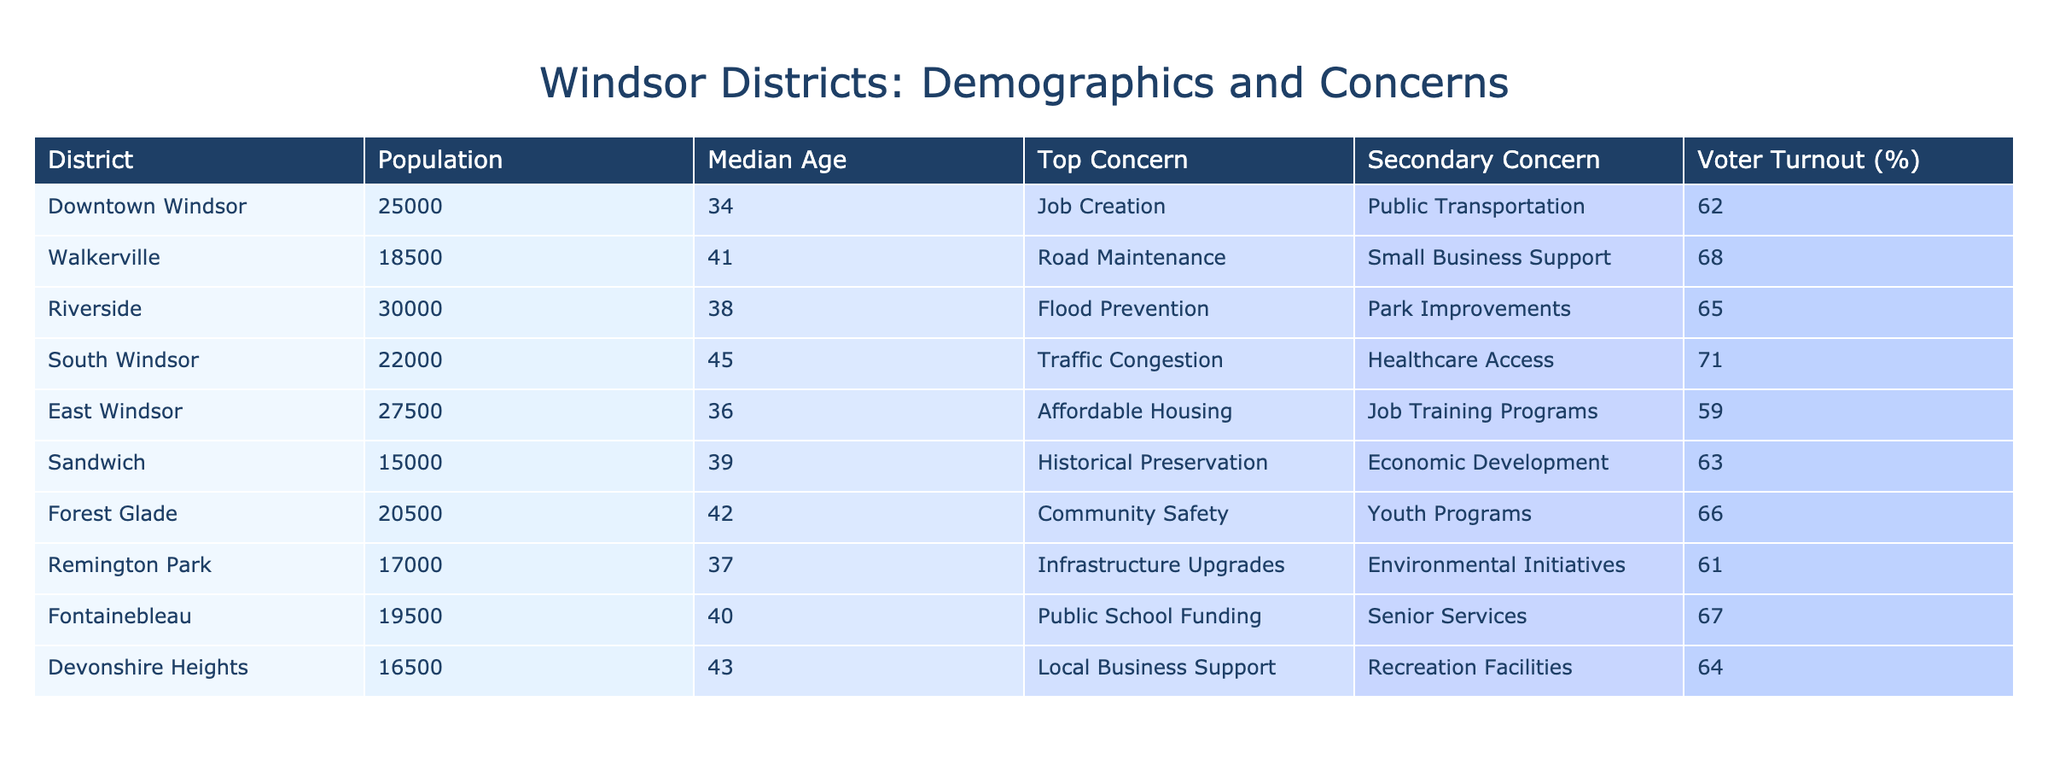What is the median age of residents in Riverside? The table lists Riverside with a median age of 38. Since the question is directly asking for a specific value in the table, it can be identified easily.
Answer: 38 Which district has the highest voter turnout percentage? By examining the voter turnout column, the district with the highest percentage is South Windsor at 71%. It is a direct retrieval question that looks for a specific value from the table.
Answer: South Windsor What is the average voter turnout for all districts? To calculate the average, sum the voter turnout percentages: (62 + 68 + 65 + 71 + 59 + 63 + 66 + 61 + 67 + 64) =  646. Then, divide by the number of districts (10): 646 / 10 = 64.6.
Answer: 64.6 Is job creation the top concern in East Windsor? The table states that the top concern in East Windsor is affordable housing, not job creation. Thus, this is a fact-based question that can be answered with a direct comparison from the table.
Answer: No Which district has traffic congestion as a concern? By checking the "Top Concern" column, it is clear that South Windsor has traffic congestion listed as a top concern. This question requires scanning through the table to find the relevant district.
Answer: South Windsor What are the secondary concerns for districts with a median age over 40? The districts with a median age over 40 are Walkerville (Small Business Support), South Windsor (Healthcare Access), Sandwich (Economic Development), and Devonshire Heights (Recreation Facilities). The secondary concerns are identified by filtering these districts from the table.
Answer: Small Business Support, Healthcare Access, Economic Development, Recreation Facilities How many districts have affordable housing as a top concern? The table shows that affordable housing is the top concern only in East Windsor. Thus, this requires checking the specific rows matching the concern.
Answer: 1 Are there more districts concerned about public transportation or road maintenance? By examining the top concerns: Public Transportation is the top concern in Downtown Windsor, and Road Maintenance is the top concern in Walkerville. There are equal concerns of 1 district each, resulting in a comparative analysis between two concerns across the districts.
Answer: Equal What is the total population of all districts combined? To find the total population, add the populations of all districts: (25000 + 18500 + 30000 + 22000 + 27500 + 15000 + 20500 + 17000 + 19500 + 16500) =  205000. This is a straightforward compositional question where values are summed.
Answer: 205000 